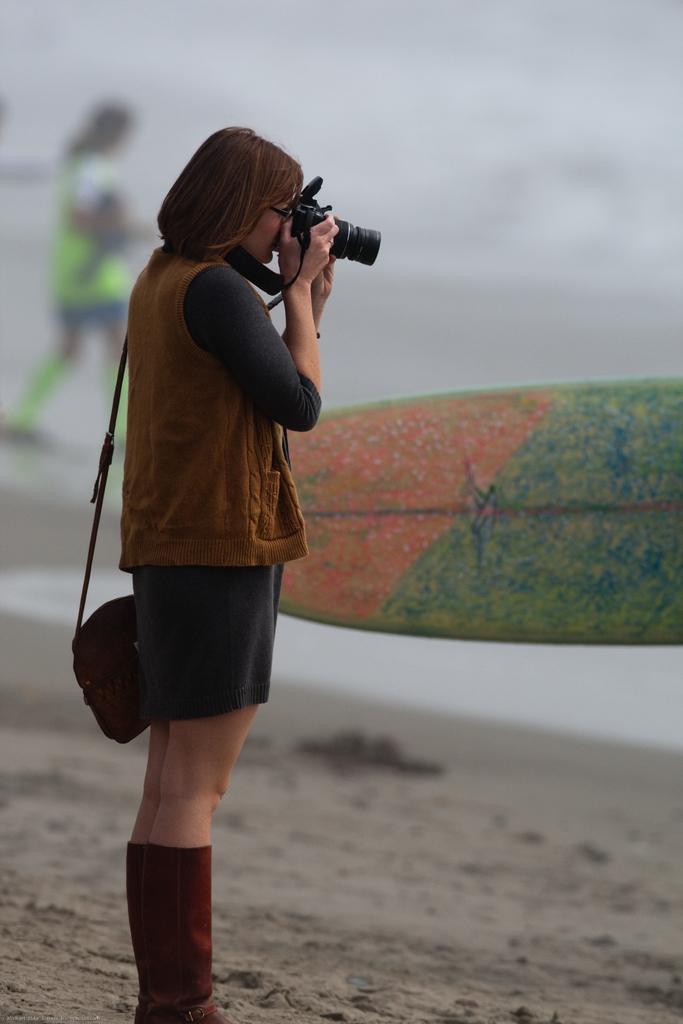Could you give a brief overview of what you see in this image? This picture is clicked outside the city. On the left there is a person wearing a sling bag, standing on the ground, holding a camera and seems to be taking pictures. The background of the image is blur. In the background there is a person and we can see a surfboard. 